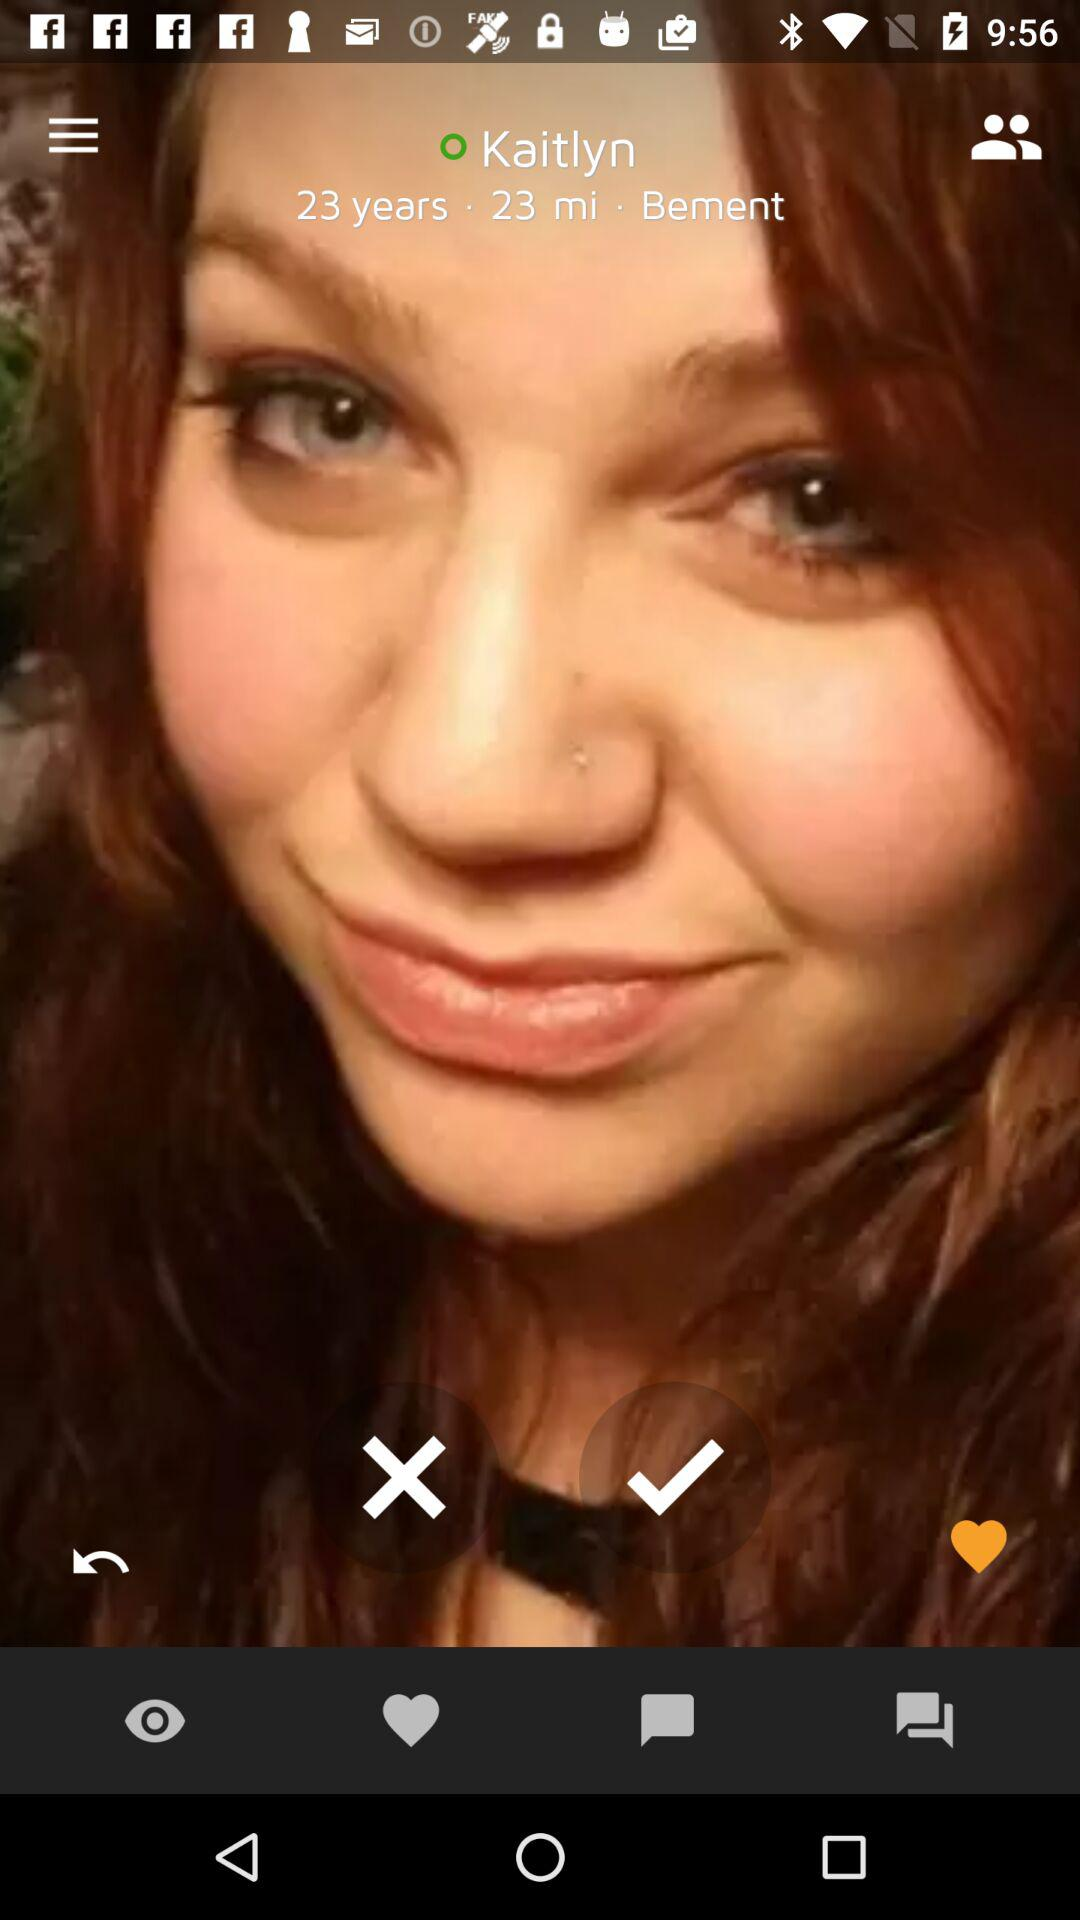What is the user name? The user name is Kaitlyn. 